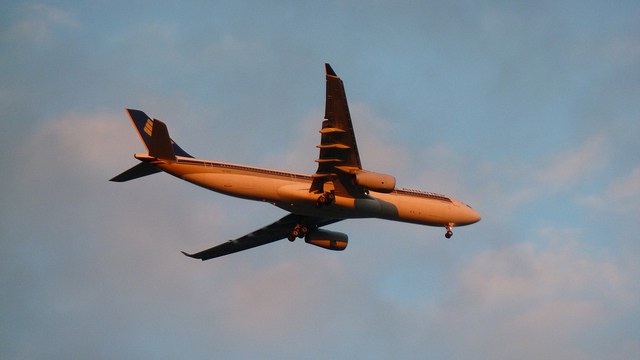<image>What word is on the underside of the wings? I don't know what word is on the underside of the wings. There might be 'us navy', 'fly', or 'airline name' or might be nothing. Why do planes fly like this at times? It is unknown why planes fly like this at times. It could be due to landing, turning, descending, or taking off. What word is on the underside of the wings? I don't know what word is on the underside of the wings. It seems there is no word. Why do planes fly like this at times? I don't know why planes fly like this at times. It can be for various reasons such as landing, turning, descending, taking off, or aerodynamics. It may also depend on the conditions. 